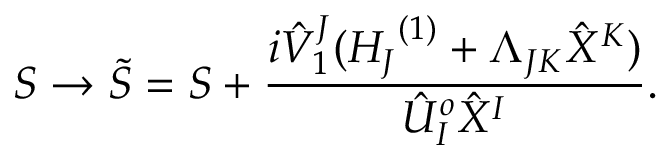<formula> <loc_0><loc_0><loc_500><loc_500>S \rightarrow { \tilde { S } } = S + \frac { i { { \hat { V } } _ { 1 } } ^ { J } ( { H _ { J } } ^ { ( 1 ) } + \Lambda _ { J K } { \hat { X } } ^ { K } ) } { { \hat { U } } _ { I } ^ { o } { \hat { X } } ^ { I } } .</formula> 